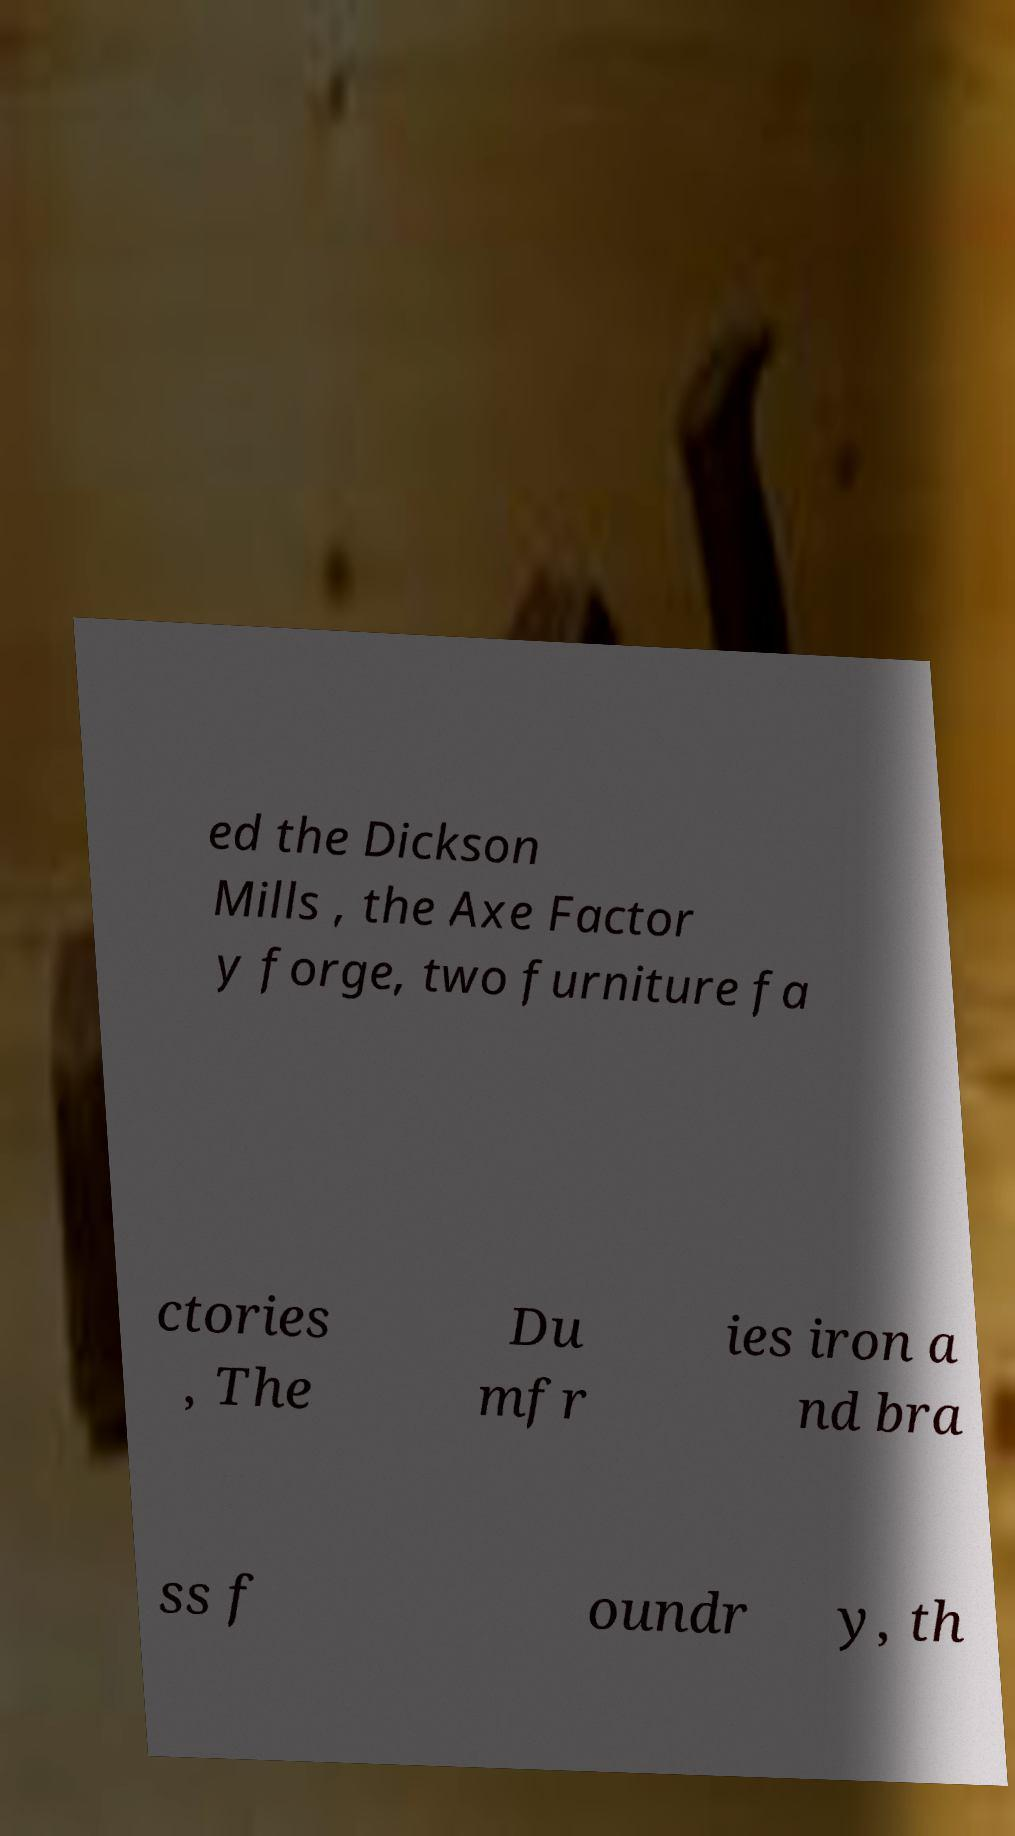For documentation purposes, I need the text within this image transcribed. Could you provide that? ed the Dickson Mills , the Axe Factor y forge, two furniture fa ctories , The Du mfr ies iron a nd bra ss f oundr y, th 